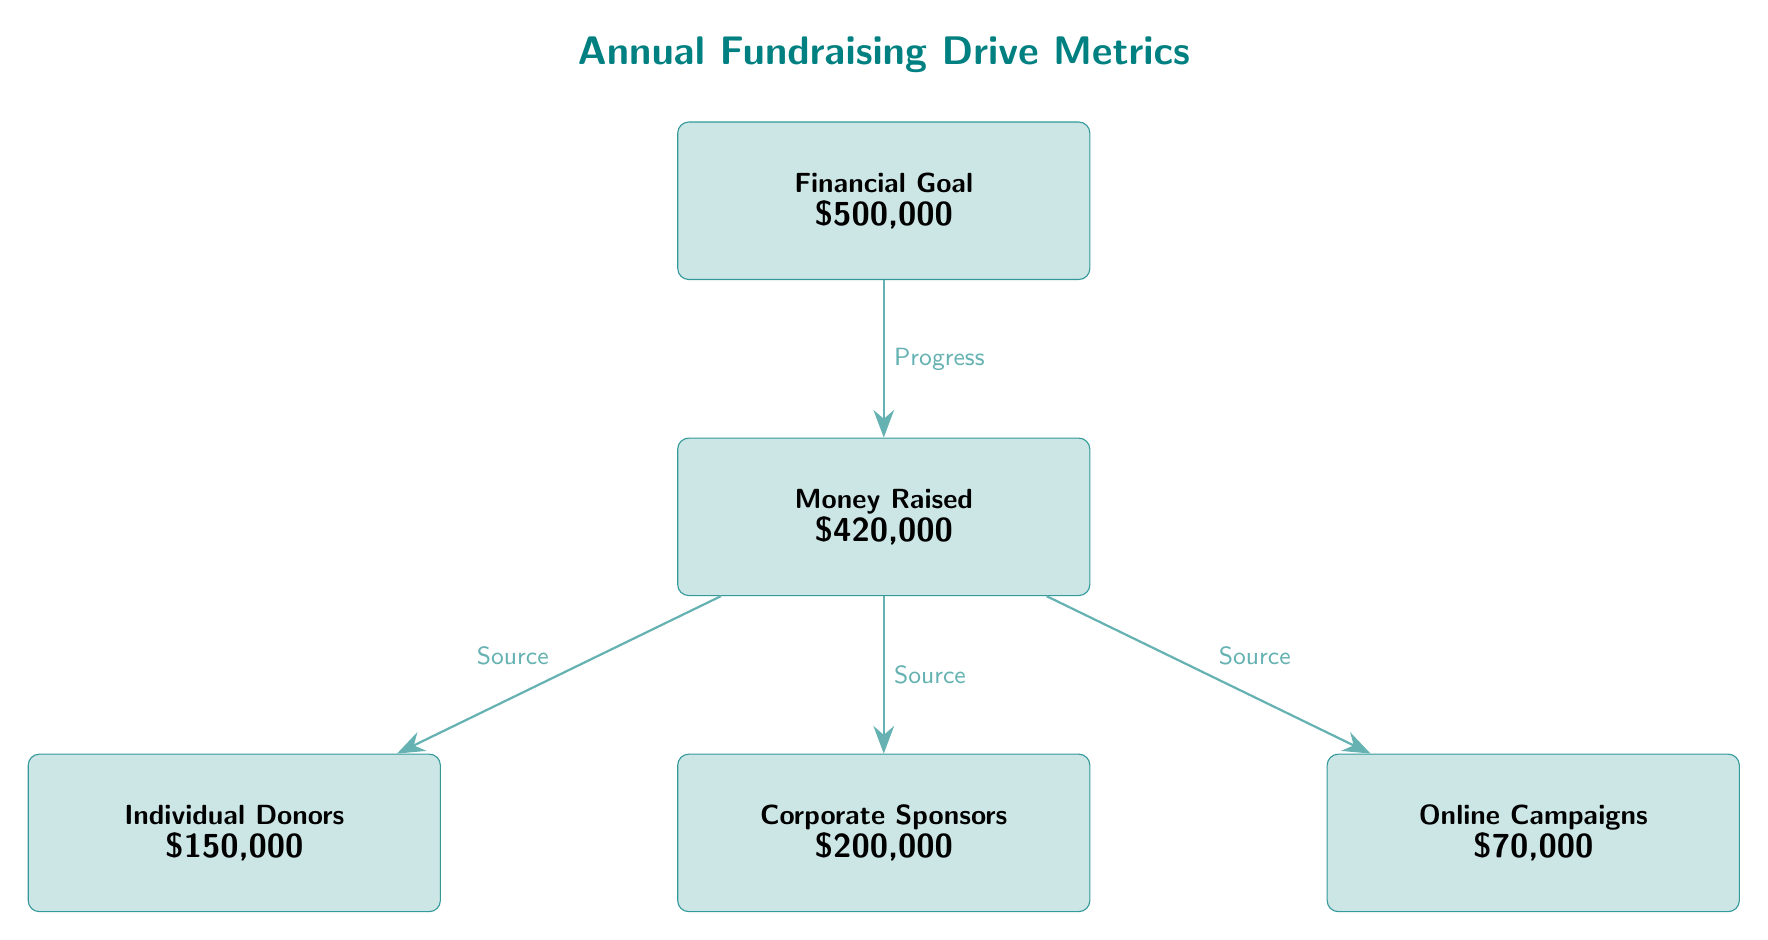What is the financial goal for the fundraising drive? The diagram clearly states the financial goal at the top in the "Financial Goal" box, which is specified as $500,000.
Answer: $500,000 How much money was raised so far? The diagram provides this information in the "Money Raised" box, which specifies that $420,000 has been raised.
Answer: $420,000 What is the amount raised from individual donors? Looking at the "Individual Donors" box, the diagram indicates that they contributed $150,000.
Answer: $150,000 Which source contributed the most to the fundraising total? The diagram shows that the "Corporate Sponsors" box, representing $200,000, is the tallest among the sources of donations, indicating that this is the highest contribution.
Answer: Corporate Sponsors What is the total from online campaigns? The "Online Campaigns" box in the diagram mentions that this source raised $70,000.
Answer: $70,000 What is the relationship between the financial goal and the money raised? The arrow between "Financial Goal" and "Money Raised" labeled "Progress" indicates that the money raised is a measure of progress towards achieving the financial goal.
Answer: Progress How many sources of donations are listed in the diagram? There are three distinct boxes under "Money Raised" representing sources: individual donors, corporate sponsors, and online campaigns, totaling to three sources.
Answer: 3 What percentage of the financial goal has been raised? To find the percentage, divide the money raised ($420,000) by the financial goal ($500,000) and multiply by 100, which results in 84%.
Answer: 84% Which node is directly linked to "Money Raised" with an arrow? The nodes connected by arrows to "Money Raised" are "Individual Donors," "Corporate Sponsors," and "Online Campaigns," illustrating how these sources contribute.
Answer: Individual Donors, Corporate Sponsors, Online Campaigns 